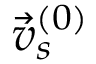Convert formula to latex. <formula><loc_0><loc_0><loc_500><loc_500>\vec { v } _ { s } ^ { ( 0 ) }</formula> 